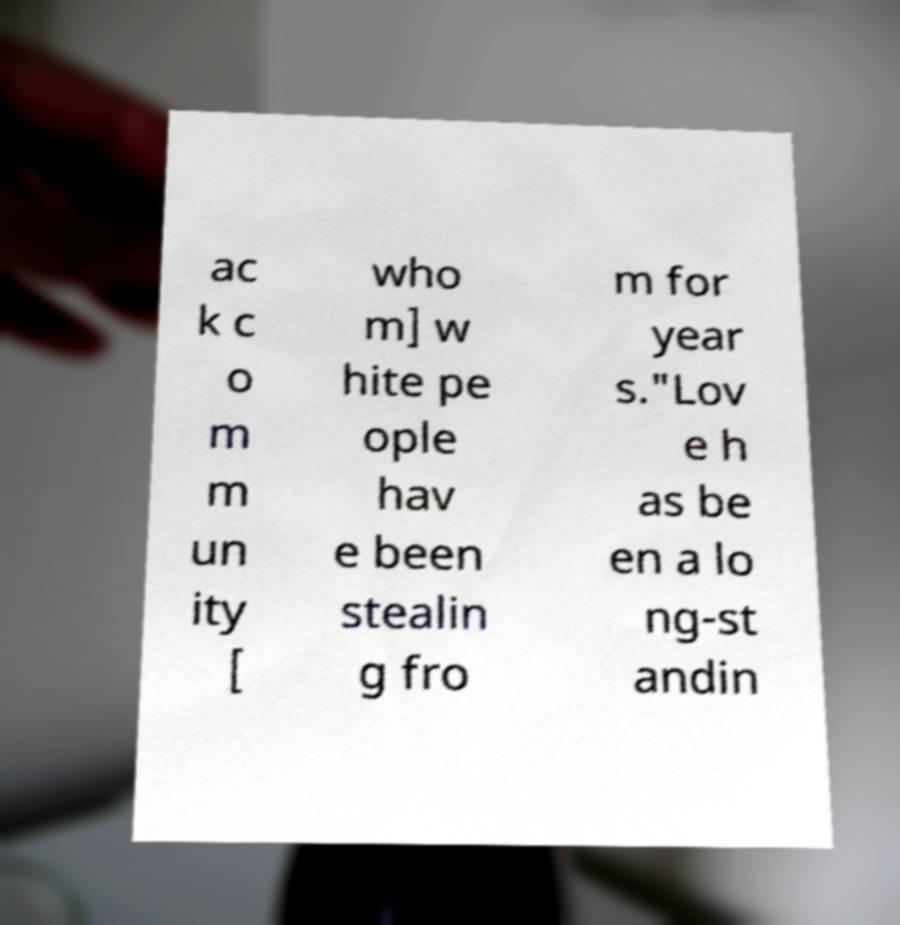Please identify and transcribe the text found in this image. ac k c o m m un ity [ who m] w hite pe ople hav e been stealin g fro m for year s."Lov e h as be en a lo ng-st andin 